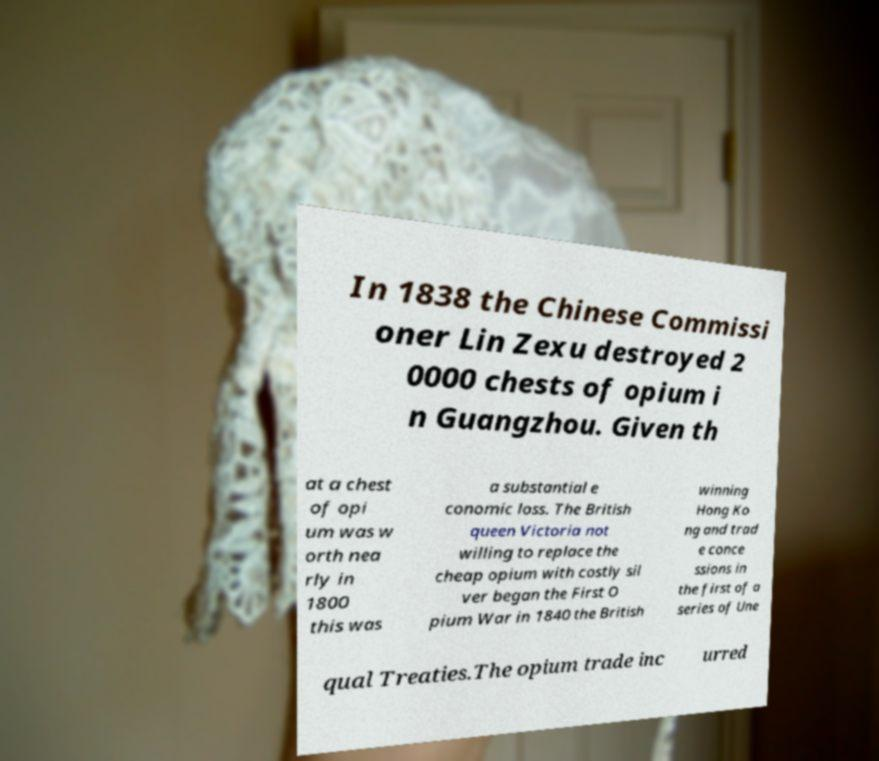Could you extract and type out the text from this image? In 1838 the Chinese Commissi oner Lin Zexu destroyed 2 0000 chests of opium i n Guangzhou. Given th at a chest of opi um was w orth nea rly in 1800 this was a substantial e conomic loss. The British queen Victoria not willing to replace the cheap opium with costly sil ver began the First O pium War in 1840 the British winning Hong Ko ng and trad e conce ssions in the first of a series of Une qual Treaties.The opium trade inc urred 